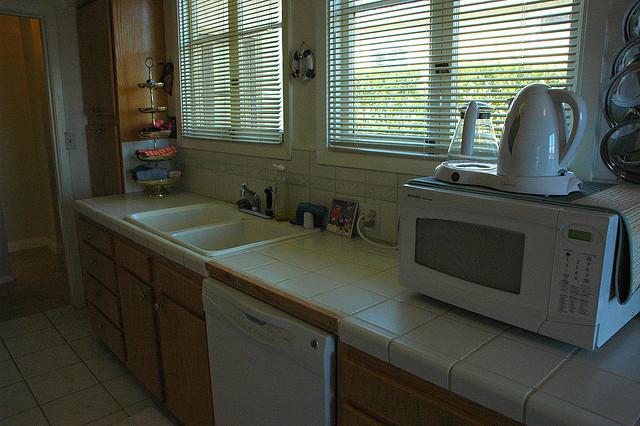Are any dishes on the counter?
Be succinct. No. What color is the dishwasher?
Short answer required. White. Is the light on or off?
Keep it brief. Off. What is the countertop made of?
Concise answer only. Tile. 